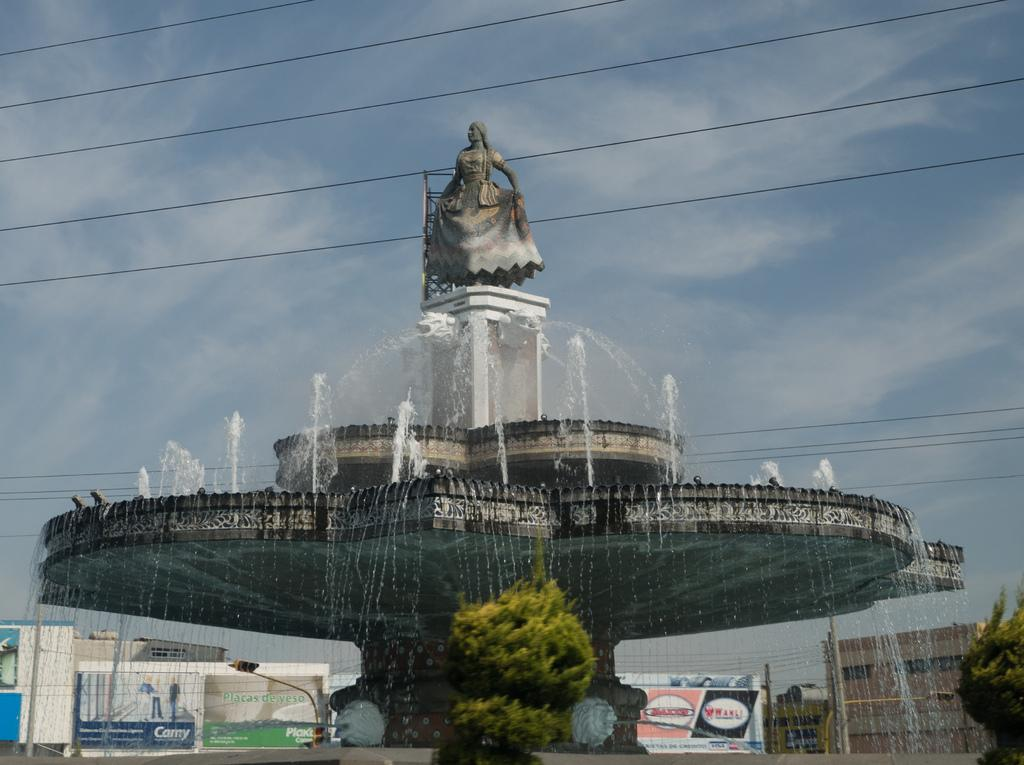What is the main feature in the middle of the image? There is a fountain and a statue in the middle of the image. What can be seen in the background of the image? There are advertisements, buildings, electric poles, electric cables, trees, and the sky visible in the background of the image. What is the condition of the sky in the image? The sky is visible in the background of the image, and there are clouds present. What type of pie is being sold by the farmer in the image? There is no farmer or pie present in the image. 